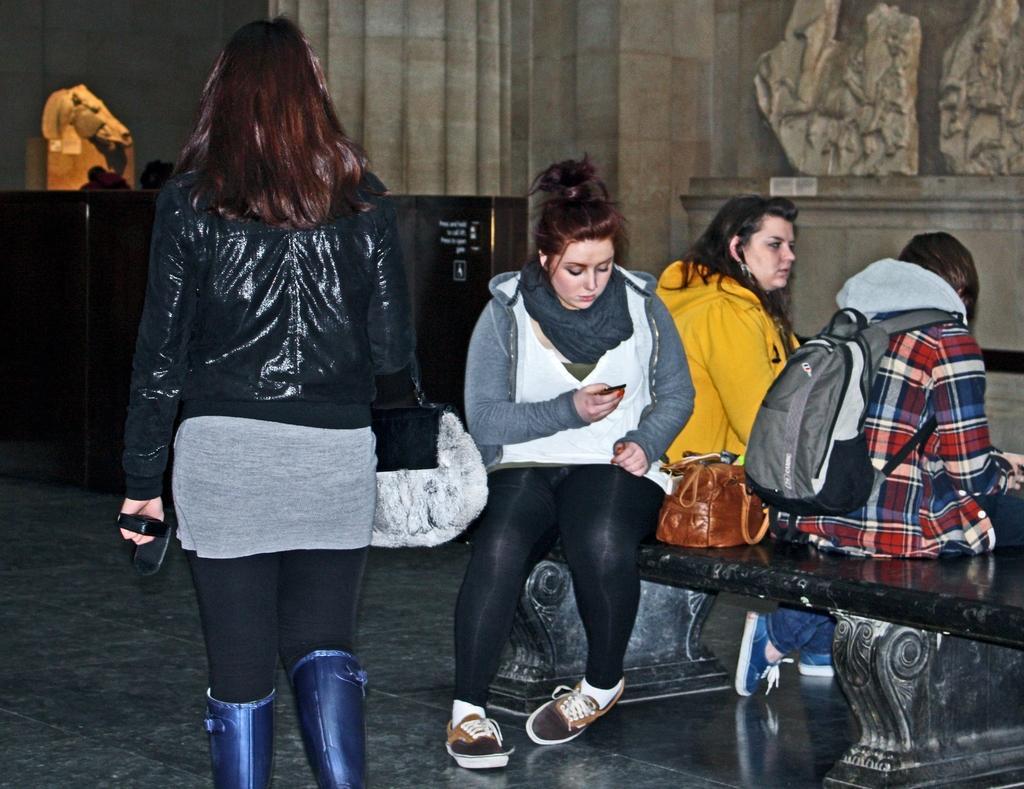Can you describe this image briefly? In the picture there are our women, three women are sitting on a bench, one woman is walking,behind the woman there is a table and some statue on the table , in the background there is a cement wall, among the woman who are sitting one woman wore check shirt and she is wearing grey color bag, another woman left side to her is wearing yellow color jacket another third woman is sitting back side to them there is a brown bag beside her she is operating a mobile phone. 